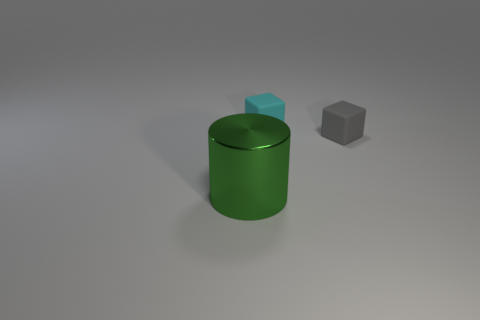Add 2 big purple metallic blocks. How many objects exist? 5 Subtract all gray cubes. How many cubes are left? 1 Subtract all cubes. How many objects are left? 1 Subtract 1 cylinders. How many cylinders are left? 0 Subtract all cyan cylinders. Subtract all blue spheres. How many cylinders are left? 1 Subtract all cyan matte things. Subtract all big matte objects. How many objects are left? 2 Add 1 tiny gray objects. How many tiny gray objects are left? 2 Add 1 small matte balls. How many small matte balls exist? 1 Subtract 0 red balls. How many objects are left? 3 